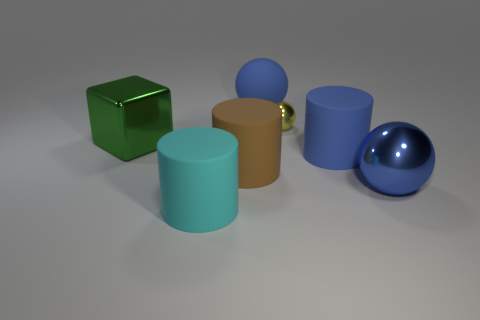Subtract all large spheres. How many spheres are left? 1 Add 2 purple things. How many objects exist? 9 Subtract all blue spheres. How many spheres are left? 1 Subtract all blue cubes. How many blue spheres are left? 2 Add 2 brown things. How many brown things exist? 3 Subtract 0 brown blocks. How many objects are left? 7 Subtract all cubes. How many objects are left? 6 Subtract 1 balls. How many balls are left? 2 Subtract all brown blocks. Subtract all brown cylinders. How many blocks are left? 1 Subtract all big blue metallic spheres. Subtract all small red metal blocks. How many objects are left? 6 